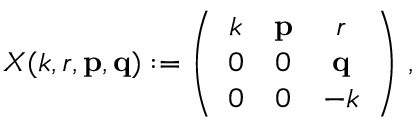<formula> <loc_0><loc_0><loc_500><loc_500>X ( k , r , { p } , { q } ) \colon = \left ( \begin{array} { c c c } { k } & { p } & { r } \\ { 0 } & { 0 } & { q } \\ { 0 } & { 0 } & { - k } \end{array} \right ) \, ,</formula> 